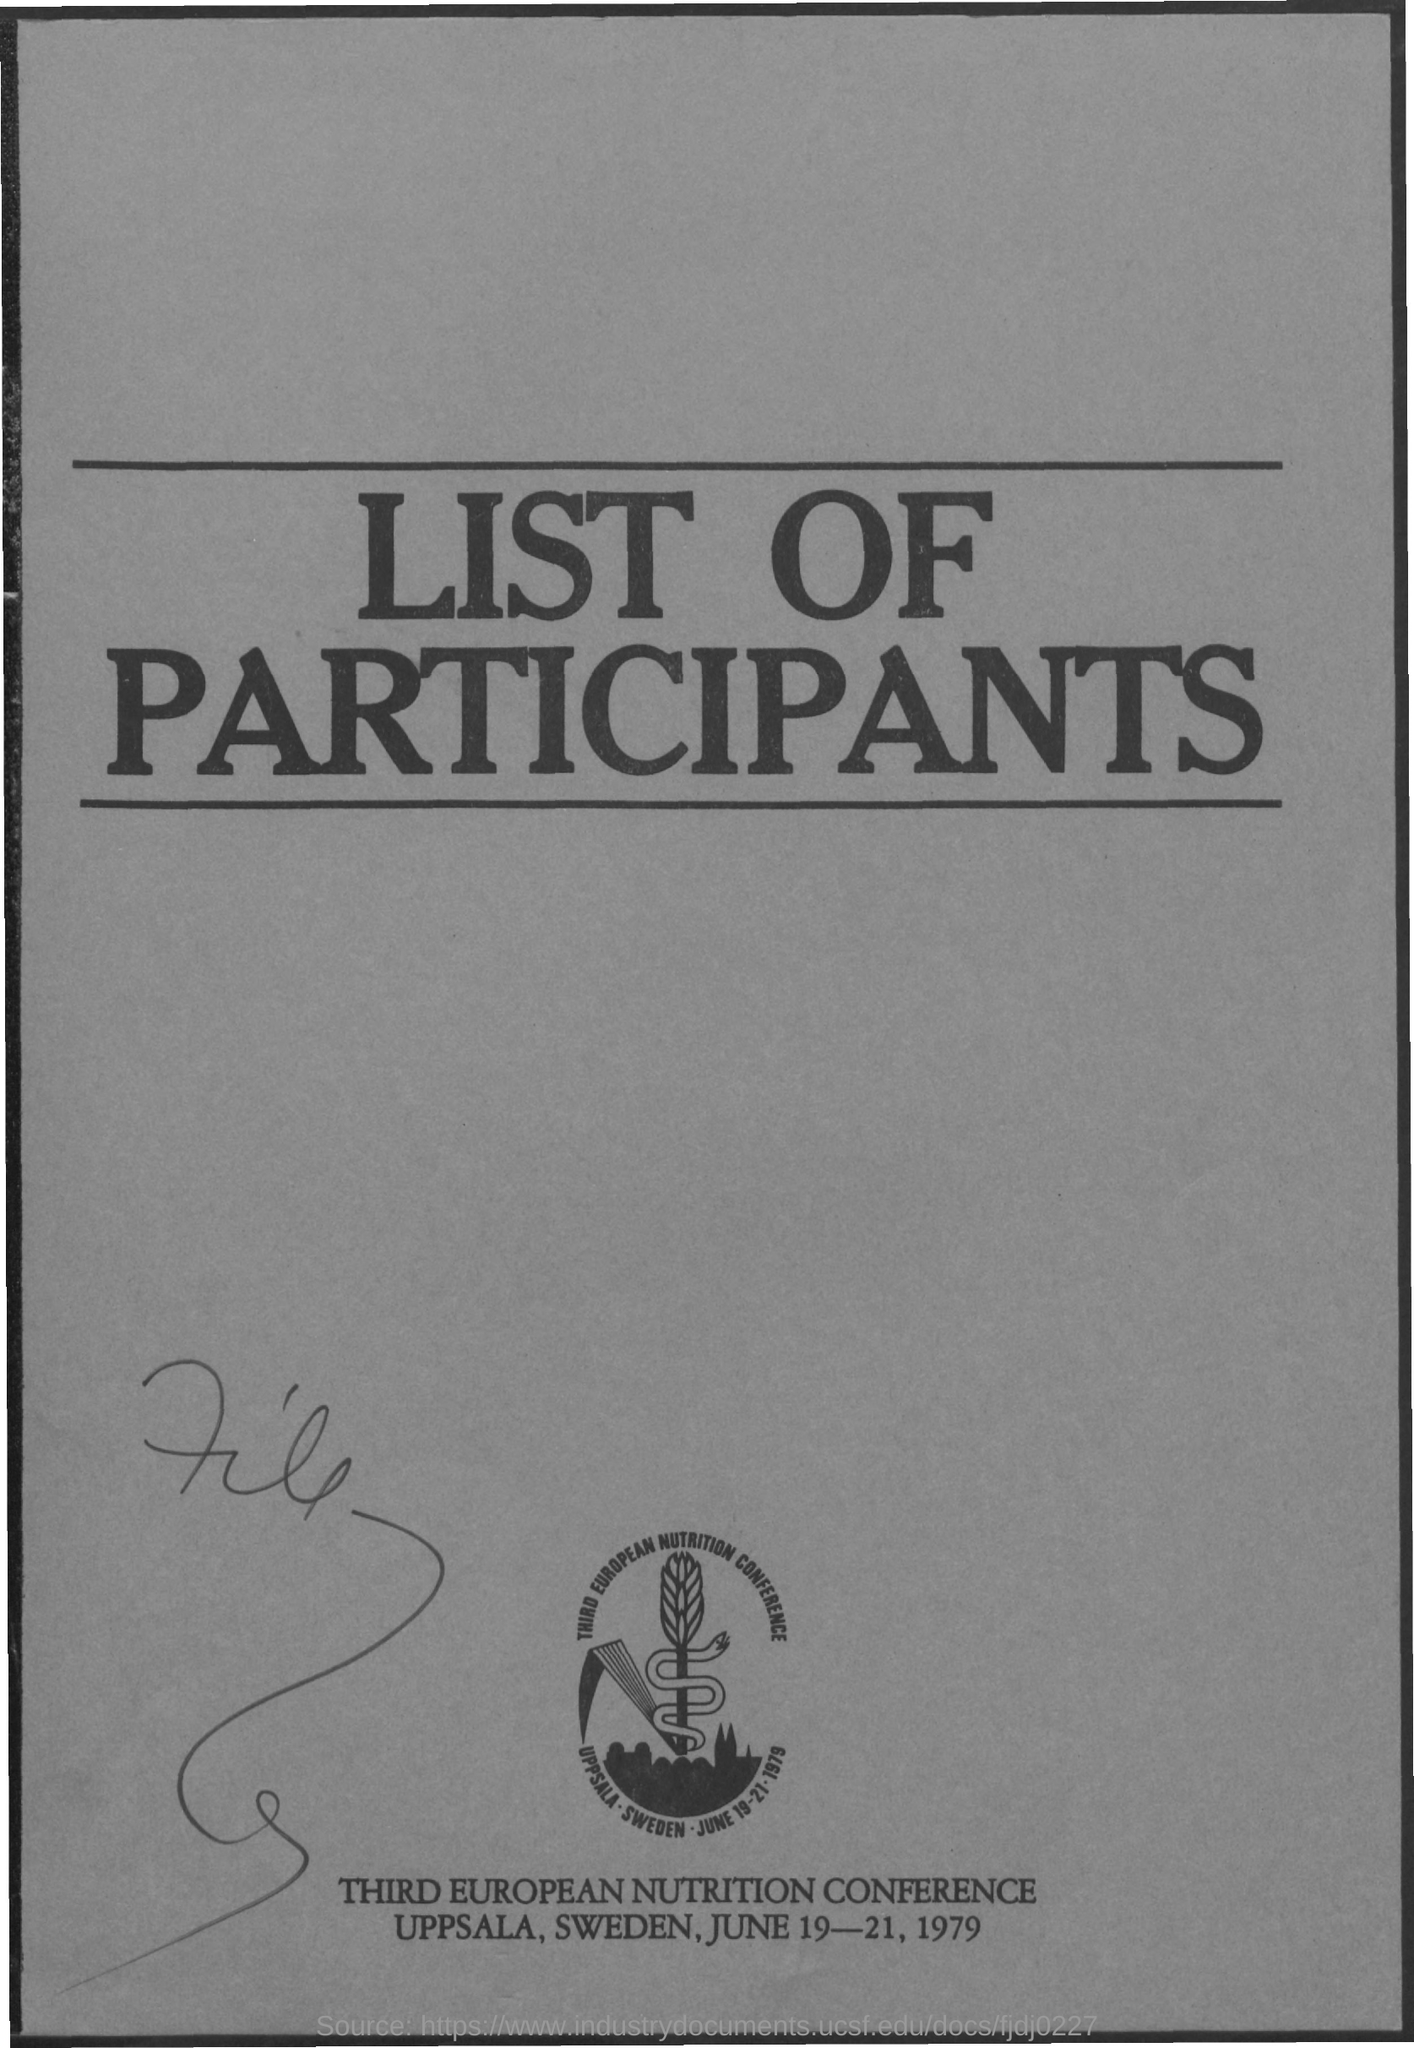What is the name of the conference ?
Your response must be concise. Third European Nutrition Conference. On which dates the conference was going to be held ?
Your response must be concise. June 19-21, 1979. 